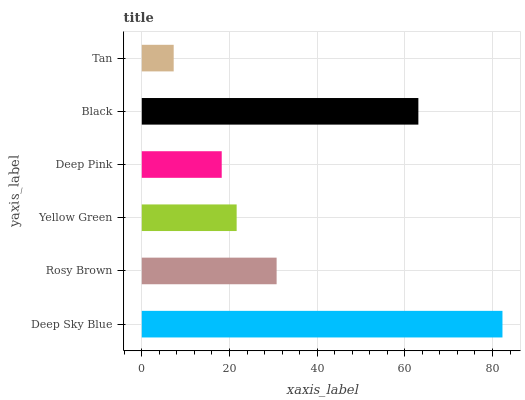Is Tan the minimum?
Answer yes or no. Yes. Is Deep Sky Blue the maximum?
Answer yes or no. Yes. Is Rosy Brown the minimum?
Answer yes or no. No. Is Rosy Brown the maximum?
Answer yes or no. No. Is Deep Sky Blue greater than Rosy Brown?
Answer yes or no. Yes. Is Rosy Brown less than Deep Sky Blue?
Answer yes or no. Yes. Is Rosy Brown greater than Deep Sky Blue?
Answer yes or no. No. Is Deep Sky Blue less than Rosy Brown?
Answer yes or no. No. Is Rosy Brown the high median?
Answer yes or no. Yes. Is Yellow Green the low median?
Answer yes or no. Yes. Is Yellow Green the high median?
Answer yes or no. No. Is Black the low median?
Answer yes or no. No. 